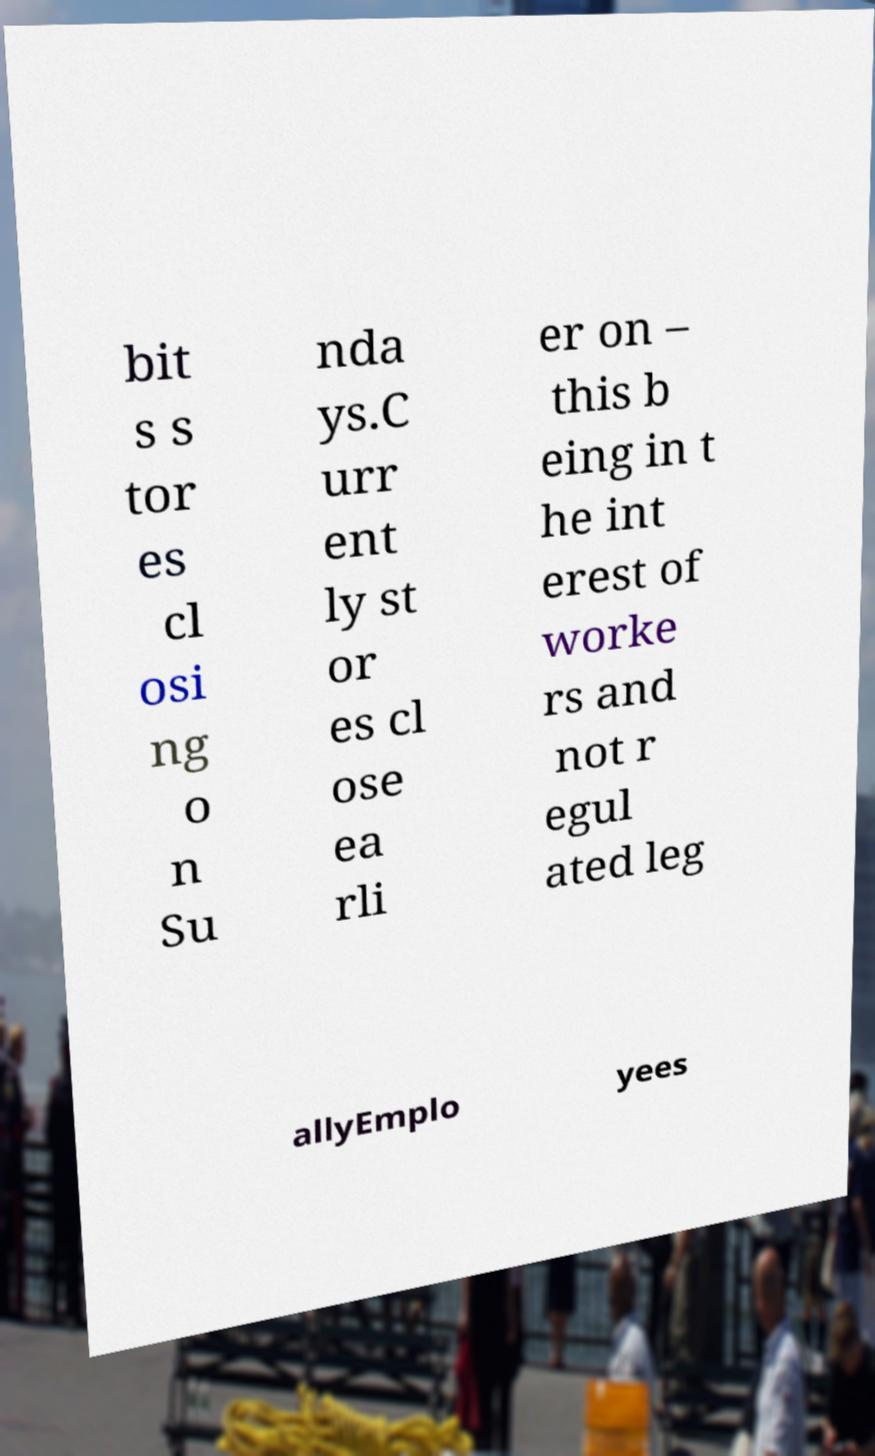For documentation purposes, I need the text within this image transcribed. Could you provide that? bit s s tor es cl osi ng o n Su nda ys.C urr ent ly st or es cl ose ea rli er on – this b eing in t he int erest of worke rs and not r egul ated leg allyEmplo yees 